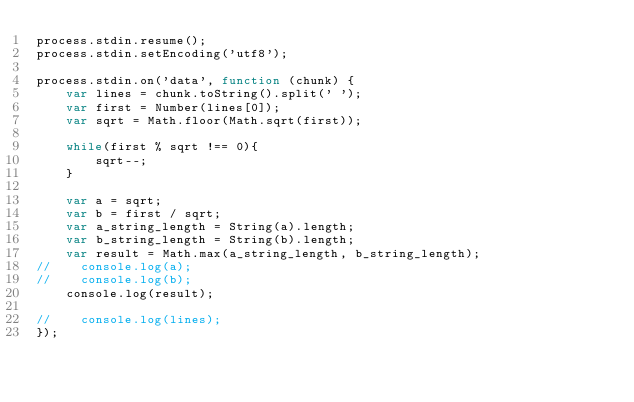Convert code to text. <code><loc_0><loc_0><loc_500><loc_500><_JavaScript_>process.stdin.resume();
process.stdin.setEncoding('utf8');

process.stdin.on('data', function (chunk) {
    var lines = chunk.toString().split(' ');
    var first = Number(lines[0]);
    var sqrt = Math.floor(Math.sqrt(first));
    
    while(first % sqrt !== 0){
        sqrt--;
    }
    
    var a = sqrt;
    var b = first / sqrt;
    var a_string_length = String(a).length;
    var b_string_length = String(b).length;
    var result = Math.max(a_string_length, b_string_length);
//    console.log(a);
//    console.log(b);
    console.log(result);
    
//    console.log(lines);
});</code> 